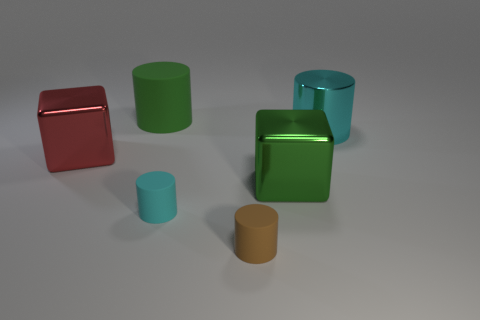There is a rubber object to the left of the small rubber cylinder that is behind the tiny matte cylinder that is in front of the small cyan cylinder; what color is it?
Provide a short and direct response. Green. Is the material of the big red cube the same as the large green block?
Keep it short and to the point. Yes. How many brown things are either big cubes or cylinders?
Make the answer very short. 1. There is a brown rubber object; what number of big blocks are in front of it?
Make the answer very short. 0. Is the number of big gray rubber objects greater than the number of small things?
Provide a short and direct response. No. What is the shape of the matte object that is behind the cyan object behind the red shiny cube?
Ensure brevity in your answer.  Cylinder. Does the big rubber cylinder have the same color as the metal cylinder?
Your response must be concise. No. Are there more small cyan cylinders that are left of the small cyan cylinder than green matte cylinders?
Offer a terse response. No. There is a small matte thing that is in front of the cyan matte thing; what number of large cyan cylinders are in front of it?
Ensure brevity in your answer.  0. Is the large green thing behind the large cyan shiny object made of the same material as the cube that is to the right of the tiny brown object?
Your answer should be very brief. No. 